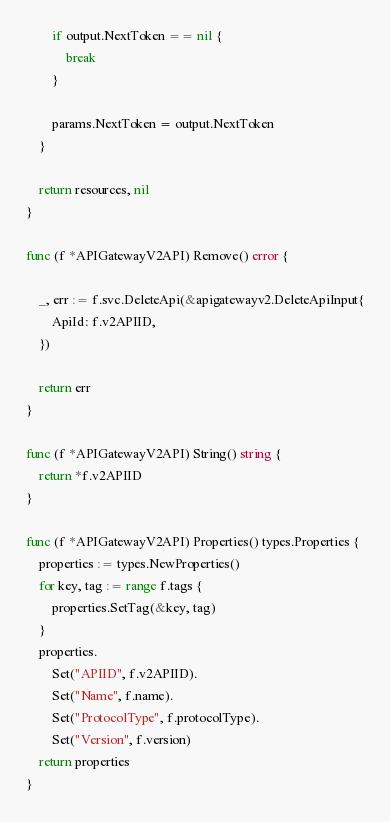<code> <loc_0><loc_0><loc_500><loc_500><_Go_>		if output.NextToken == nil {
			break
		}

		params.NextToken = output.NextToken
	}

	return resources, nil
}

func (f *APIGatewayV2API) Remove() error {

	_, err := f.svc.DeleteApi(&apigatewayv2.DeleteApiInput{
		ApiId: f.v2APIID,
	})

	return err
}

func (f *APIGatewayV2API) String() string {
	return *f.v2APIID
}

func (f *APIGatewayV2API) Properties() types.Properties {
	properties := types.NewProperties()
	for key, tag := range f.tags {
		properties.SetTag(&key, tag)
	}
	properties.
		Set("APIID", f.v2APIID).
		Set("Name", f.name).
		Set("ProtocolType", f.protocolType).
		Set("Version", f.version)
	return properties
}
</code> 